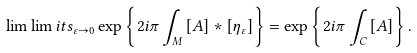Convert formula to latex. <formula><loc_0><loc_0><loc_500><loc_500>\lim \lim i t s _ { \varepsilon \to 0 } \exp \left \{ { 2 i \pi \int _ { M } { \left [ A \right ] \ast \left [ { \eta _ { \varepsilon } } \right ] } } \right \} = \exp \left \{ { 2 i \pi \int _ { C } { \left [ A \right ] } } \right \} .</formula> 